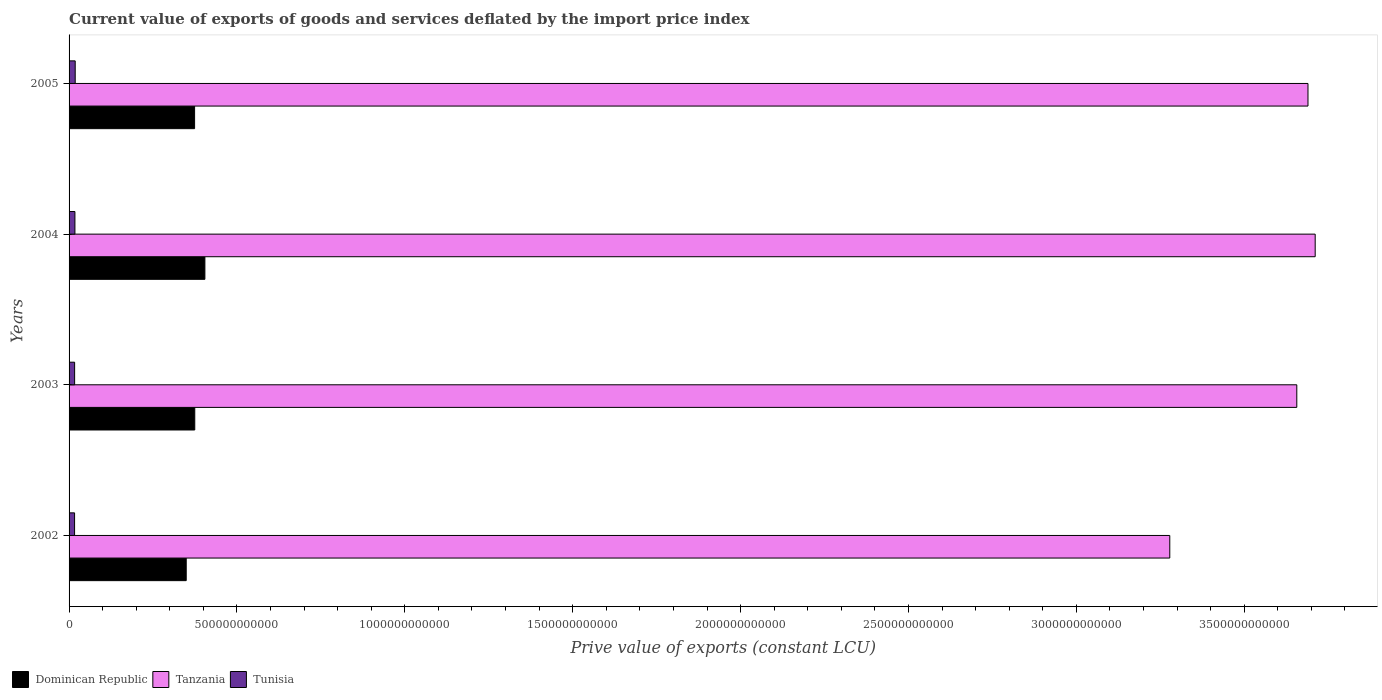How many different coloured bars are there?
Your response must be concise. 3. How many groups of bars are there?
Offer a terse response. 4. Are the number of bars per tick equal to the number of legend labels?
Offer a very short reply. Yes. How many bars are there on the 2nd tick from the top?
Give a very brief answer. 3. How many bars are there on the 3rd tick from the bottom?
Keep it short and to the point. 3. What is the label of the 1st group of bars from the top?
Your answer should be very brief. 2005. What is the prive value of exports in Tunisia in 2003?
Provide a succinct answer. 1.65e+1. Across all years, what is the maximum prive value of exports in Tunisia?
Ensure brevity in your answer.  1.83e+1. Across all years, what is the minimum prive value of exports in Tunisia?
Offer a terse response. 1.64e+1. What is the total prive value of exports in Tanzania in the graph?
Your answer should be very brief. 1.43e+13. What is the difference between the prive value of exports in Tanzania in 2002 and that in 2005?
Provide a succinct answer. -4.12e+11. What is the difference between the prive value of exports in Tanzania in 2004 and the prive value of exports in Dominican Republic in 2005?
Make the answer very short. 3.34e+12. What is the average prive value of exports in Tanzania per year?
Provide a short and direct response. 3.58e+12. In the year 2003, what is the difference between the prive value of exports in Tanzania and prive value of exports in Dominican Republic?
Your answer should be very brief. 3.28e+12. What is the ratio of the prive value of exports in Dominican Republic in 2002 to that in 2005?
Your response must be concise. 0.93. Is the difference between the prive value of exports in Tanzania in 2002 and 2004 greater than the difference between the prive value of exports in Dominican Republic in 2002 and 2004?
Ensure brevity in your answer.  No. What is the difference between the highest and the second highest prive value of exports in Tunisia?
Ensure brevity in your answer.  8.68e+08. What is the difference between the highest and the lowest prive value of exports in Tanzania?
Keep it short and to the point. 4.33e+11. In how many years, is the prive value of exports in Tunisia greater than the average prive value of exports in Tunisia taken over all years?
Provide a short and direct response. 2. What does the 2nd bar from the top in 2003 represents?
Ensure brevity in your answer.  Tanzania. What does the 2nd bar from the bottom in 2003 represents?
Offer a very short reply. Tanzania. How many bars are there?
Ensure brevity in your answer.  12. How many years are there in the graph?
Your answer should be very brief. 4. What is the difference between two consecutive major ticks on the X-axis?
Provide a succinct answer. 5.00e+11. Are the values on the major ticks of X-axis written in scientific E-notation?
Keep it short and to the point. No. Does the graph contain any zero values?
Provide a succinct answer. No. Does the graph contain grids?
Keep it short and to the point. No. Where does the legend appear in the graph?
Ensure brevity in your answer.  Bottom left. How are the legend labels stacked?
Provide a succinct answer. Horizontal. What is the title of the graph?
Keep it short and to the point. Current value of exports of goods and services deflated by the import price index. What is the label or title of the X-axis?
Your answer should be compact. Prive value of exports (constant LCU). What is the label or title of the Y-axis?
Keep it short and to the point. Years. What is the Prive value of exports (constant LCU) of Dominican Republic in 2002?
Offer a very short reply. 3.49e+11. What is the Prive value of exports (constant LCU) of Tanzania in 2002?
Provide a short and direct response. 3.28e+12. What is the Prive value of exports (constant LCU) in Tunisia in 2002?
Make the answer very short. 1.64e+1. What is the Prive value of exports (constant LCU) in Dominican Republic in 2003?
Your response must be concise. 3.74e+11. What is the Prive value of exports (constant LCU) in Tanzania in 2003?
Provide a succinct answer. 3.66e+12. What is the Prive value of exports (constant LCU) of Tunisia in 2003?
Provide a short and direct response. 1.65e+1. What is the Prive value of exports (constant LCU) of Dominican Republic in 2004?
Keep it short and to the point. 4.05e+11. What is the Prive value of exports (constant LCU) in Tanzania in 2004?
Your answer should be very brief. 3.71e+12. What is the Prive value of exports (constant LCU) of Tunisia in 2004?
Your response must be concise. 1.74e+1. What is the Prive value of exports (constant LCU) of Dominican Republic in 2005?
Your answer should be compact. 3.74e+11. What is the Prive value of exports (constant LCU) in Tanzania in 2005?
Provide a short and direct response. 3.69e+12. What is the Prive value of exports (constant LCU) in Tunisia in 2005?
Keep it short and to the point. 1.83e+1. Across all years, what is the maximum Prive value of exports (constant LCU) of Dominican Republic?
Make the answer very short. 4.05e+11. Across all years, what is the maximum Prive value of exports (constant LCU) in Tanzania?
Keep it short and to the point. 3.71e+12. Across all years, what is the maximum Prive value of exports (constant LCU) of Tunisia?
Ensure brevity in your answer.  1.83e+1. Across all years, what is the minimum Prive value of exports (constant LCU) in Dominican Republic?
Provide a short and direct response. 3.49e+11. Across all years, what is the minimum Prive value of exports (constant LCU) in Tanzania?
Keep it short and to the point. 3.28e+12. Across all years, what is the minimum Prive value of exports (constant LCU) in Tunisia?
Your answer should be very brief. 1.64e+1. What is the total Prive value of exports (constant LCU) of Dominican Republic in the graph?
Offer a very short reply. 1.50e+12. What is the total Prive value of exports (constant LCU) in Tanzania in the graph?
Offer a terse response. 1.43e+13. What is the total Prive value of exports (constant LCU) of Tunisia in the graph?
Give a very brief answer. 6.86e+1. What is the difference between the Prive value of exports (constant LCU) of Dominican Republic in 2002 and that in 2003?
Provide a short and direct response. -2.55e+1. What is the difference between the Prive value of exports (constant LCU) in Tanzania in 2002 and that in 2003?
Provide a short and direct response. -3.78e+11. What is the difference between the Prive value of exports (constant LCU) of Tunisia in 2002 and that in 2003?
Keep it short and to the point. -1.37e+08. What is the difference between the Prive value of exports (constant LCU) of Dominican Republic in 2002 and that in 2004?
Your answer should be compact. -5.56e+1. What is the difference between the Prive value of exports (constant LCU) in Tanzania in 2002 and that in 2004?
Provide a succinct answer. -4.33e+11. What is the difference between the Prive value of exports (constant LCU) in Tunisia in 2002 and that in 2004?
Your answer should be compact. -1.03e+09. What is the difference between the Prive value of exports (constant LCU) of Dominican Republic in 2002 and that in 2005?
Your answer should be compact. -2.49e+1. What is the difference between the Prive value of exports (constant LCU) of Tanzania in 2002 and that in 2005?
Offer a terse response. -4.12e+11. What is the difference between the Prive value of exports (constant LCU) in Tunisia in 2002 and that in 2005?
Offer a very short reply. -1.89e+09. What is the difference between the Prive value of exports (constant LCU) of Dominican Republic in 2003 and that in 2004?
Keep it short and to the point. -3.02e+1. What is the difference between the Prive value of exports (constant LCU) of Tanzania in 2003 and that in 2004?
Your answer should be compact. -5.48e+1. What is the difference between the Prive value of exports (constant LCU) of Tunisia in 2003 and that in 2004?
Your response must be concise. -8.88e+08. What is the difference between the Prive value of exports (constant LCU) in Dominican Republic in 2003 and that in 2005?
Your response must be concise. 5.11e+08. What is the difference between the Prive value of exports (constant LCU) of Tanzania in 2003 and that in 2005?
Give a very brief answer. -3.33e+1. What is the difference between the Prive value of exports (constant LCU) of Tunisia in 2003 and that in 2005?
Your answer should be compact. -1.76e+09. What is the difference between the Prive value of exports (constant LCU) in Dominican Republic in 2004 and that in 2005?
Your answer should be very brief. 3.07e+1. What is the difference between the Prive value of exports (constant LCU) of Tanzania in 2004 and that in 2005?
Provide a succinct answer. 2.15e+1. What is the difference between the Prive value of exports (constant LCU) in Tunisia in 2004 and that in 2005?
Offer a very short reply. -8.68e+08. What is the difference between the Prive value of exports (constant LCU) in Dominican Republic in 2002 and the Prive value of exports (constant LCU) in Tanzania in 2003?
Your response must be concise. -3.31e+12. What is the difference between the Prive value of exports (constant LCU) of Dominican Republic in 2002 and the Prive value of exports (constant LCU) of Tunisia in 2003?
Offer a very short reply. 3.32e+11. What is the difference between the Prive value of exports (constant LCU) of Tanzania in 2002 and the Prive value of exports (constant LCU) of Tunisia in 2003?
Keep it short and to the point. 3.26e+12. What is the difference between the Prive value of exports (constant LCU) in Dominican Republic in 2002 and the Prive value of exports (constant LCU) in Tanzania in 2004?
Make the answer very short. -3.36e+12. What is the difference between the Prive value of exports (constant LCU) of Dominican Republic in 2002 and the Prive value of exports (constant LCU) of Tunisia in 2004?
Offer a terse response. 3.31e+11. What is the difference between the Prive value of exports (constant LCU) in Tanzania in 2002 and the Prive value of exports (constant LCU) in Tunisia in 2004?
Ensure brevity in your answer.  3.26e+12. What is the difference between the Prive value of exports (constant LCU) of Dominican Republic in 2002 and the Prive value of exports (constant LCU) of Tanzania in 2005?
Ensure brevity in your answer.  -3.34e+12. What is the difference between the Prive value of exports (constant LCU) of Dominican Republic in 2002 and the Prive value of exports (constant LCU) of Tunisia in 2005?
Your answer should be compact. 3.31e+11. What is the difference between the Prive value of exports (constant LCU) in Tanzania in 2002 and the Prive value of exports (constant LCU) in Tunisia in 2005?
Offer a very short reply. 3.26e+12. What is the difference between the Prive value of exports (constant LCU) in Dominican Republic in 2003 and the Prive value of exports (constant LCU) in Tanzania in 2004?
Make the answer very short. -3.34e+12. What is the difference between the Prive value of exports (constant LCU) in Dominican Republic in 2003 and the Prive value of exports (constant LCU) in Tunisia in 2004?
Offer a terse response. 3.57e+11. What is the difference between the Prive value of exports (constant LCU) of Tanzania in 2003 and the Prive value of exports (constant LCU) of Tunisia in 2004?
Offer a very short reply. 3.64e+12. What is the difference between the Prive value of exports (constant LCU) in Dominican Republic in 2003 and the Prive value of exports (constant LCU) in Tanzania in 2005?
Make the answer very short. -3.32e+12. What is the difference between the Prive value of exports (constant LCU) in Dominican Republic in 2003 and the Prive value of exports (constant LCU) in Tunisia in 2005?
Ensure brevity in your answer.  3.56e+11. What is the difference between the Prive value of exports (constant LCU) in Tanzania in 2003 and the Prive value of exports (constant LCU) in Tunisia in 2005?
Give a very brief answer. 3.64e+12. What is the difference between the Prive value of exports (constant LCU) of Dominican Republic in 2004 and the Prive value of exports (constant LCU) of Tanzania in 2005?
Give a very brief answer. -3.29e+12. What is the difference between the Prive value of exports (constant LCU) of Dominican Republic in 2004 and the Prive value of exports (constant LCU) of Tunisia in 2005?
Make the answer very short. 3.86e+11. What is the difference between the Prive value of exports (constant LCU) in Tanzania in 2004 and the Prive value of exports (constant LCU) in Tunisia in 2005?
Offer a very short reply. 3.69e+12. What is the average Prive value of exports (constant LCU) of Dominican Republic per year?
Make the answer very short. 3.75e+11. What is the average Prive value of exports (constant LCU) in Tanzania per year?
Make the answer very short. 3.58e+12. What is the average Prive value of exports (constant LCU) of Tunisia per year?
Your answer should be compact. 1.72e+1. In the year 2002, what is the difference between the Prive value of exports (constant LCU) in Dominican Republic and Prive value of exports (constant LCU) in Tanzania?
Your response must be concise. -2.93e+12. In the year 2002, what is the difference between the Prive value of exports (constant LCU) in Dominican Republic and Prive value of exports (constant LCU) in Tunisia?
Your answer should be compact. 3.33e+11. In the year 2002, what is the difference between the Prive value of exports (constant LCU) of Tanzania and Prive value of exports (constant LCU) of Tunisia?
Give a very brief answer. 3.26e+12. In the year 2003, what is the difference between the Prive value of exports (constant LCU) of Dominican Republic and Prive value of exports (constant LCU) of Tanzania?
Provide a short and direct response. -3.28e+12. In the year 2003, what is the difference between the Prive value of exports (constant LCU) in Dominican Republic and Prive value of exports (constant LCU) in Tunisia?
Make the answer very short. 3.58e+11. In the year 2003, what is the difference between the Prive value of exports (constant LCU) of Tanzania and Prive value of exports (constant LCU) of Tunisia?
Your response must be concise. 3.64e+12. In the year 2004, what is the difference between the Prive value of exports (constant LCU) in Dominican Republic and Prive value of exports (constant LCU) in Tanzania?
Give a very brief answer. -3.31e+12. In the year 2004, what is the difference between the Prive value of exports (constant LCU) of Dominican Republic and Prive value of exports (constant LCU) of Tunisia?
Give a very brief answer. 3.87e+11. In the year 2004, what is the difference between the Prive value of exports (constant LCU) in Tanzania and Prive value of exports (constant LCU) in Tunisia?
Your answer should be compact. 3.69e+12. In the year 2005, what is the difference between the Prive value of exports (constant LCU) in Dominican Republic and Prive value of exports (constant LCU) in Tanzania?
Give a very brief answer. -3.32e+12. In the year 2005, what is the difference between the Prive value of exports (constant LCU) in Dominican Republic and Prive value of exports (constant LCU) in Tunisia?
Give a very brief answer. 3.56e+11. In the year 2005, what is the difference between the Prive value of exports (constant LCU) of Tanzania and Prive value of exports (constant LCU) of Tunisia?
Ensure brevity in your answer.  3.67e+12. What is the ratio of the Prive value of exports (constant LCU) in Dominican Republic in 2002 to that in 2003?
Ensure brevity in your answer.  0.93. What is the ratio of the Prive value of exports (constant LCU) in Tanzania in 2002 to that in 2003?
Your response must be concise. 0.9. What is the ratio of the Prive value of exports (constant LCU) of Tunisia in 2002 to that in 2003?
Your response must be concise. 0.99. What is the ratio of the Prive value of exports (constant LCU) in Dominican Republic in 2002 to that in 2004?
Ensure brevity in your answer.  0.86. What is the ratio of the Prive value of exports (constant LCU) in Tanzania in 2002 to that in 2004?
Ensure brevity in your answer.  0.88. What is the ratio of the Prive value of exports (constant LCU) of Tunisia in 2002 to that in 2004?
Offer a very short reply. 0.94. What is the ratio of the Prive value of exports (constant LCU) in Tanzania in 2002 to that in 2005?
Offer a very short reply. 0.89. What is the ratio of the Prive value of exports (constant LCU) in Tunisia in 2002 to that in 2005?
Ensure brevity in your answer.  0.9. What is the ratio of the Prive value of exports (constant LCU) in Dominican Republic in 2003 to that in 2004?
Offer a terse response. 0.93. What is the ratio of the Prive value of exports (constant LCU) of Tanzania in 2003 to that in 2004?
Keep it short and to the point. 0.99. What is the ratio of the Prive value of exports (constant LCU) in Tunisia in 2003 to that in 2004?
Provide a short and direct response. 0.95. What is the ratio of the Prive value of exports (constant LCU) of Tanzania in 2003 to that in 2005?
Make the answer very short. 0.99. What is the ratio of the Prive value of exports (constant LCU) in Tunisia in 2003 to that in 2005?
Your response must be concise. 0.9. What is the ratio of the Prive value of exports (constant LCU) of Dominican Republic in 2004 to that in 2005?
Your answer should be very brief. 1.08. What is the ratio of the Prive value of exports (constant LCU) of Tunisia in 2004 to that in 2005?
Keep it short and to the point. 0.95. What is the difference between the highest and the second highest Prive value of exports (constant LCU) in Dominican Republic?
Offer a very short reply. 3.02e+1. What is the difference between the highest and the second highest Prive value of exports (constant LCU) of Tanzania?
Your answer should be compact. 2.15e+1. What is the difference between the highest and the second highest Prive value of exports (constant LCU) in Tunisia?
Offer a very short reply. 8.68e+08. What is the difference between the highest and the lowest Prive value of exports (constant LCU) of Dominican Republic?
Keep it short and to the point. 5.56e+1. What is the difference between the highest and the lowest Prive value of exports (constant LCU) of Tanzania?
Your answer should be compact. 4.33e+11. What is the difference between the highest and the lowest Prive value of exports (constant LCU) in Tunisia?
Offer a very short reply. 1.89e+09. 